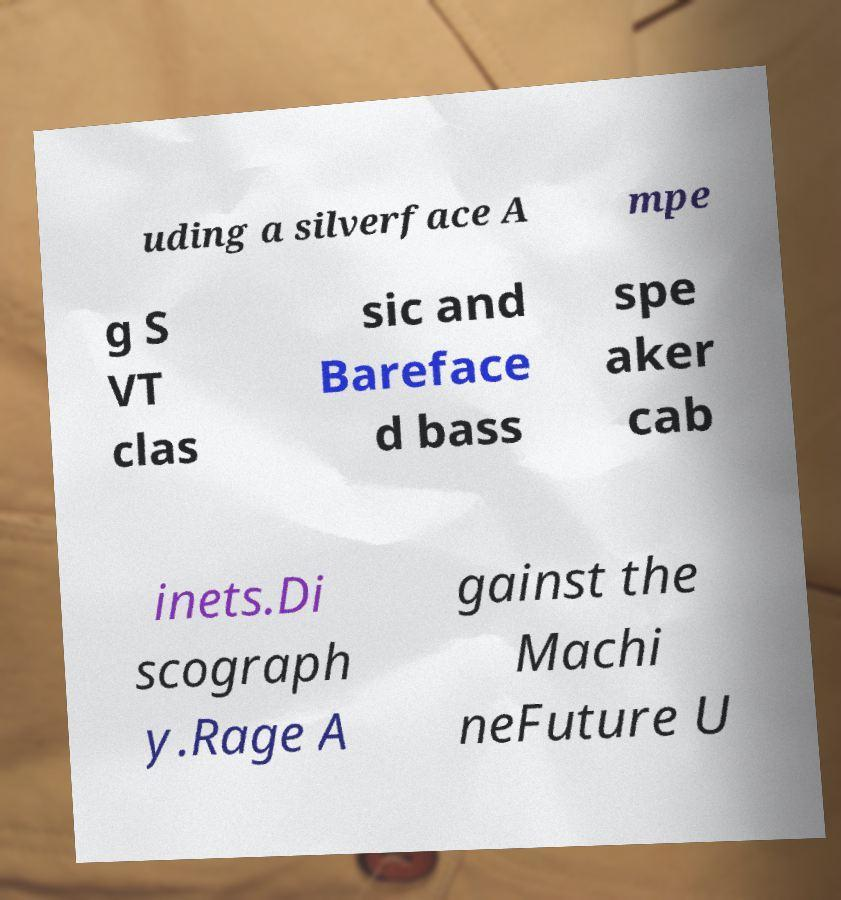Could you extract and type out the text from this image? uding a silverface A mpe g S VT clas sic and Bareface d bass spe aker cab inets.Di scograph y.Rage A gainst the Machi neFuture U 